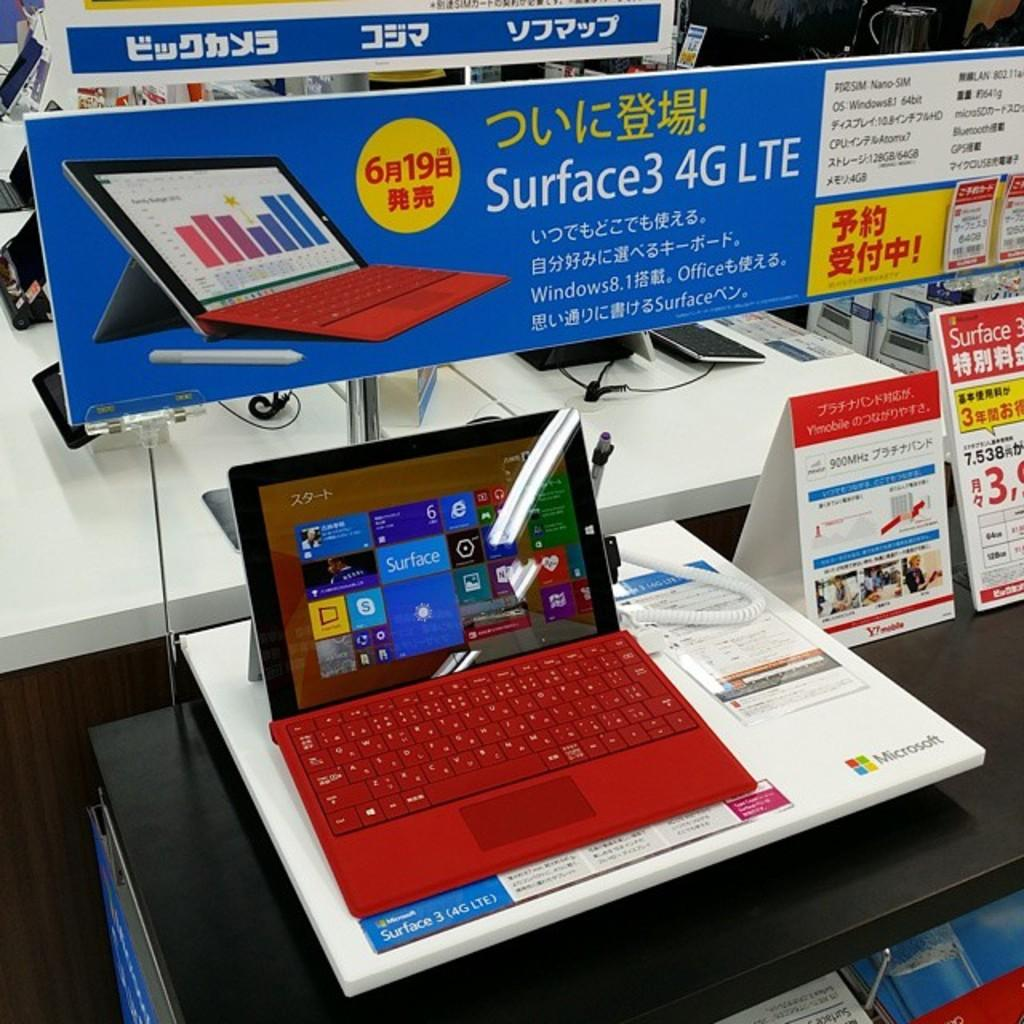What electronic device is visible in the image? There is a laptop in the image. What type of signage is present in the image? There are banners with words in the image. What is the color of the table in the image? The table in the image is white. What type of fear can be seen on the laptop's screen in the image? There is no fear visible on the laptop's screen in the image, as it is a device for displaying information and not an expression of emotion. 